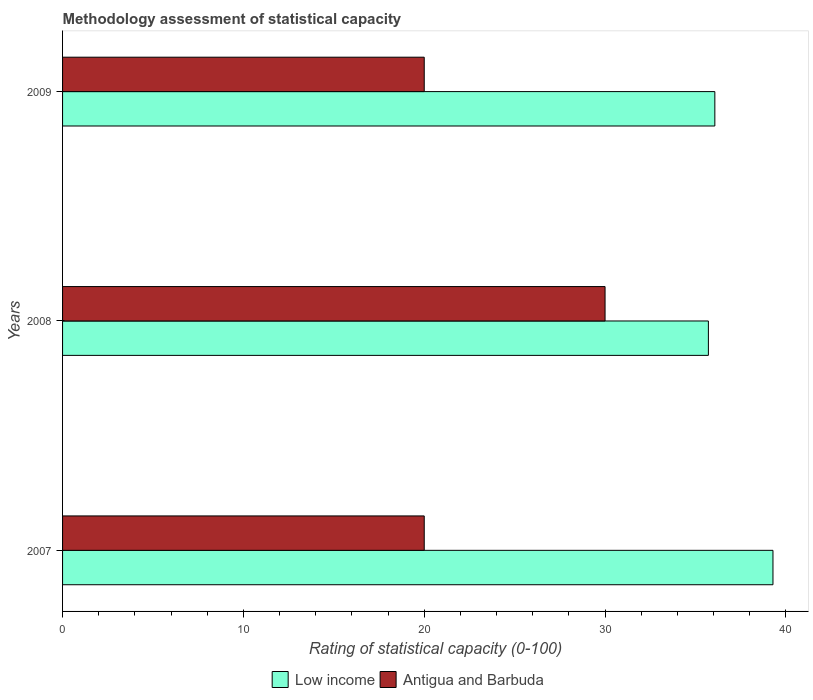How many different coloured bars are there?
Offer a very short reply. 2. Are the number of bars per tick equal to the number of legend labels?
Provide a succinct answer. Yes. Are the number of bars on each tick of the Y-axis equal?
Keep it short and to the point. Yes. How many bars are there on the 2nd tick from the bottom?
Give a very brief answer. 2. What is the rating of statistical capacity in Low income in 2008?
Provide a short and direct response. 35.71. Across all years, what is the maximum rating of statistical capacity in Low income?
Your response must be concise. 39.29. Across all years, what is the minimum rating of statistical capacity in Antigua and Barbuda?
Your response must be concise. 20. What is the total rating of statistical capacity in Antigua and Barbuda in the graph?
Provide a succinct answer. 70. What is the difference between the rating of statistical capacity in Low income in 2008 and the rating of statistical capacity in Antigua and Barbuda in 2007?
Your answer should be very brief. 15.71. What is the average rating of statistical capacity in Low income per year?
Offer a very short reply. 37.02. In the year 2007, what is the difference between the rating of statistical capacity in Low income and rating of statistical capacity in Antigua and Barbuda?
Your answer should be very brief. 19.29. What is the ratio of the rating of statistical capacity in Antigua and Barbuda in 2008 to that in 2009?
Ensure brevity in your answer.  1.5. Is the difference between the rating of statistical capacity in Low income in 2007 and 2008 greater than the difference between the rating of statistical capacity in Antigua and Barbuda in 2007 and 2008?
Ensure brevity in your answer.  Yes. What is the difference between the highest and the lowest rating of statistical capacity in Low income?
Your answer should be very brief. 3.57. Is the sum of the rating of statistical capacity in Low income in 2007 and 2008 greater than the maximum rating of statistical capacity in Antigua and Barbuda across all years?
Provide a succinct answer. Yes. What does the 1st bar from the top in 2009 represents?
Keep it short and to the point. Antigua and Barbuda. What does the 1st bar from the bottom in 2007 represents?
Your response must be concise. Low income. How many bars are there?
Provide a succinct answer. 6. How many years are there in the graph?
Provide a succinct answer. 3. What is the difference between two consecutive major ticks on the X-axis?
Offer a terse response. 10. Are the values on the major ticks of X-axis written in scientific E-notation?
Your answer should be compact. No. Does the graph contain any zero values?
Offer a terse response. No. Does the graph contain grids?
Your answer should be compact. No. Where does the legend appear in the graph?
Provide a succinct answer. Bottom center. How many legend labels are there?
Provide a succinct answer. 2. What is the title of the graph?
Your answer should be very brief. Methodology assessment of statistical capacity. Does "China" appear as one of the legend labels in the graph?
Your answer should be compact. No. What is the label or title of the X-axis?
Offer a terse response. Rating of statistical capacity (0-100). What is the label or title of the Y-axis?
Provide a short and direct response. Years. What is the Rating of statistical capacity (0-100) of Low income in 2007?
Offer a very short reply. 39.29. What is the Rating of statistical capacity (0-100) in Low income in 2008?
Ensure brevity in your answer.  35.71. What is the Rating of statistical capacity (0-100) in Low income in 2009?
Provide a succinct answer. 36.07. Across all years, what is the maximum Rating of statistical capacity (0-100) in Low income?
Your answer should be very brief. 39.29. Across all years, what is the maximum Rating of statistical capacity (0-100) in Antigua and Barbuda?
Offer a very short reply. 30. Across all years, what is the minimum Rating of statistical capacity (0-100) of Low income?
Make the answer very short. 35.71. What is the total Rating of statistical capacity (0-100) of Low income in the graph?
Provide a short and direct response. 111.07. What is the total Rating of statistical capacity (0-100) in Antigua and Barbuda in the graph?
Provide a succinct answer. 70. What is the difference between the Rating of statistical capacity (0-100) in Low income in 2007 and that in 2008?
Your answer should be compact. 3.57. What is the difference between the Rating of statistical capacity (0-100) of Low income in 2007 and that in 2009?
Give a very brief answer. 3.21. What is the difference between the Rating of statistical capacity (0-100) in Low income in 2008 and that in 2009?
Offer a very short reply. -0.36. What is the difference between the Rating of statistical capacity (0-100) of Low income in 2007 and the Rating of statistical capacity (0-100) of Antigua and Barbuda in 2008?
Make the answer very short. 9.29. What is the difference between the Rating of statistical capacity (0-100) of Low income in 2007 and the Rating of statistical capacity (0-100) of Antigua and Barbuda in 2009?
Keep it short and to the point. 19.29. What is the difference between the Rating of statistical capacity (0-100) of Low income in 2008 and the Rating of statistical capacity (0-100) of Antigua and Barbuda in 2009?
Offer a very short reply. 15.71. What is the average Rating of statistical capacity (0-100) in Low income per year?
Offer a very short reply. 37.02. What is the average Rating of statistical capacity (0-100) of Antigua and Barbuda per year?
Make the answer very short. 23.33. In the year 2007, what is the difference between the Rating of statistical capacity (0-100) of Low income and Rating of statistical capacity (0-100) of Antigua and Barbuda?
Provide a short and direct response. 19.29. In the year 2008, what is the difference between the Rating of statistical capacity (0-100) in Low income and Rating of statistical capacity (0-100) in Antigua and Barbuda?
Make the answer very short. 5.71. In the year 2009, what is the difference between the Rating of statistical capacity (0-100) in Low income and Rating of statistical capacity (0-100) in Antigua and Barbuda?
Provide a short and direct response. 16.07. What is the ratio of the Rating of statistical capacity (0-100) of Antigua and Barbuda in 2007 to that in 2008?
Offer a very short reply. 0.67. What is the ratio of the Rating of statistical capacity (0-100) in Low income in 2007 to that in 2009?
Your answer should be very brief. 1.09. What is the ratio of the Rating of statistical capacity (0-100) of Antigua and Barbuda in 2008 to that in 2009?
Give a very brief answer. 1.5. What is the difference between the highest and the second highest Rating of statistical capacity (0-100) of Low income?
Your answer should be very brief. 3.21. What is the difference between the highest and the lowest Rating of statistical capacity (0-100) in Low income?
Make the answer very short. 3.57. What is the difference between the highest and the lowest Rating of statistical capacity (0-100) of Antigua and Barbuda?
Your answer should be very brief. 10. 